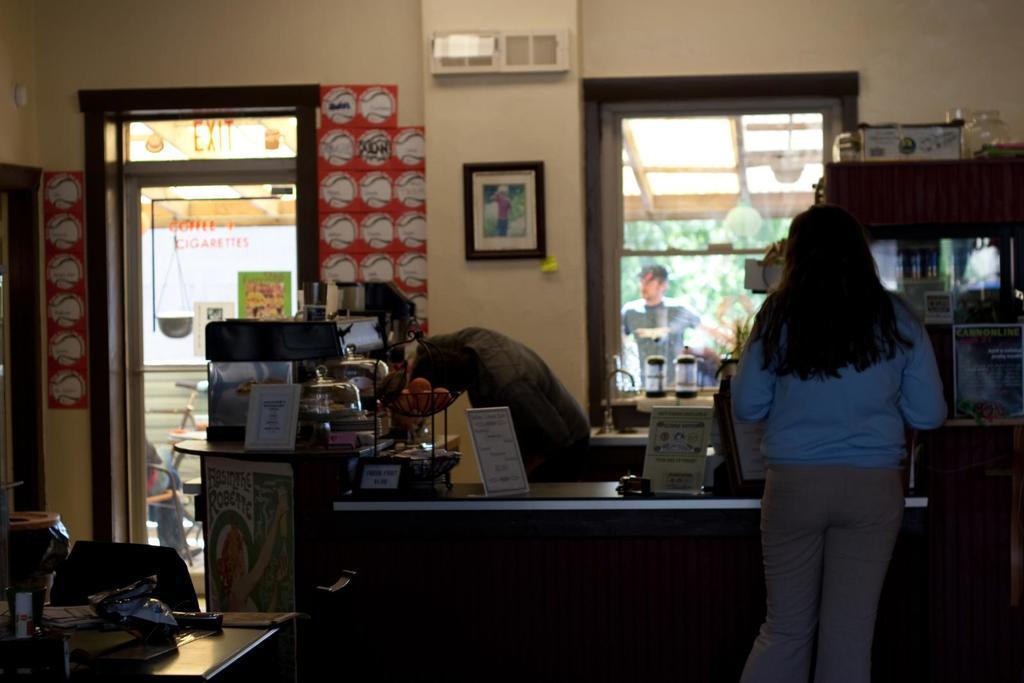Can you describe this image briefly? In this picture there is a woman and a man standing. There is a paper, box, , bowl and few other objects on the desk. There is a frame on the wall. There is a bottle and other objects on the table. There is a man standing at the background. 